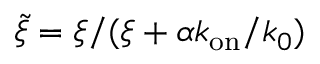<formula> <loc_0><loc_0><loc_500><loc_500>\tilde { \xi } = \xi / ( \xi + \alpha k _ { o n } / k _ { 0 } )</formula> 